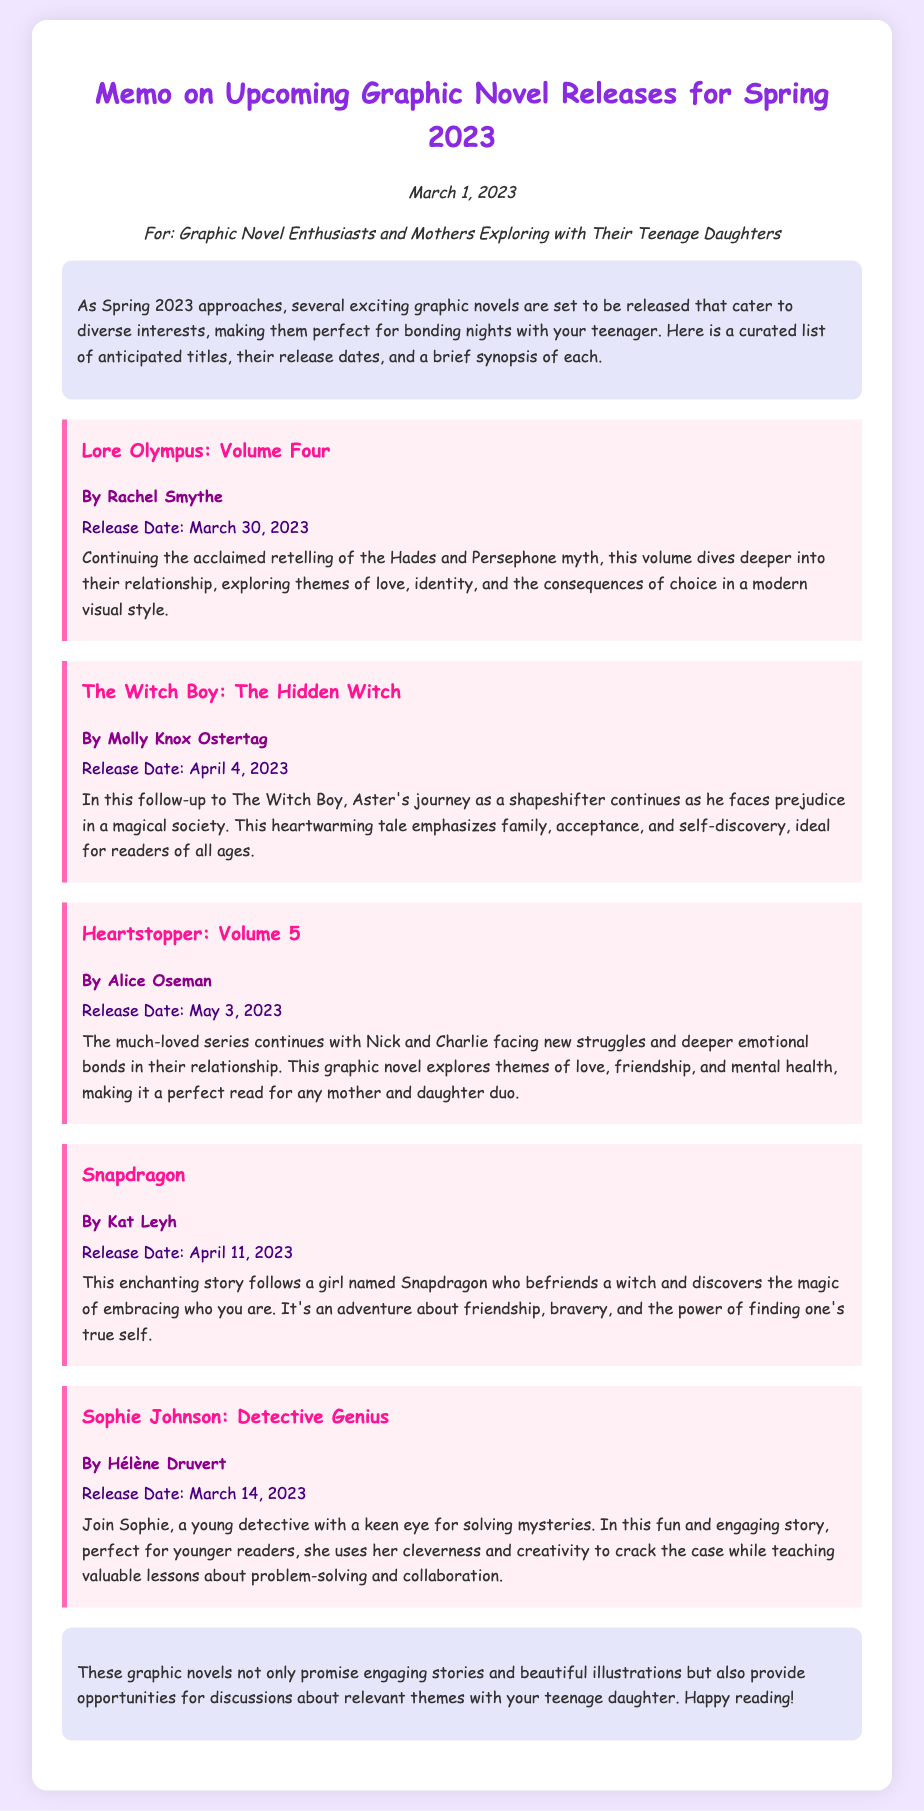What is the release date of "Lore Olympus: Volume Four"? The release date is mentioned in the document as March 30, 2023.
Answer: March 30, 2023 Who is the author of "Heartstopper: Volume 5"? The document specifies the author of this title as Alice Oseman.
Answer: Alice Oseman What themes does "Snapdragon" explore? The synopsis highlights themes of friendship, bravery, and self-discovery in the story.
Answer: Friendship, bravery, self-discovery How many graphic novels are listed in the memo? The document lists a total of five upcoming graphic novels for Spring 2023.
Answer: Five Which graphic novel is a follow-up to "The Witch Boy"? The document mentions "The Witch Boy: The Hidden Witch" as the follow-up title.
Answer: The Witch Boy: The Hidden Witch What is highlighted as a key lesson in "Sophie Johnson: Detective Genius"? The synopsis emphasizes valuable lessons about problem-solving and collaboration.
Answer: Problem-solving and collaboration What is the intended audience for this memo? The document states that it is aimed at graphic novel enthusiasts and mothers exploring with their teenage daughters.
Answer: Graphic novel enthusiasts and mothers exploring with their teenage daughters When is the release date for "The Witch Boy: The Hidden Witch"? The memo specifies the release date as April 4, 2023.
Answer: April 4, 2023 